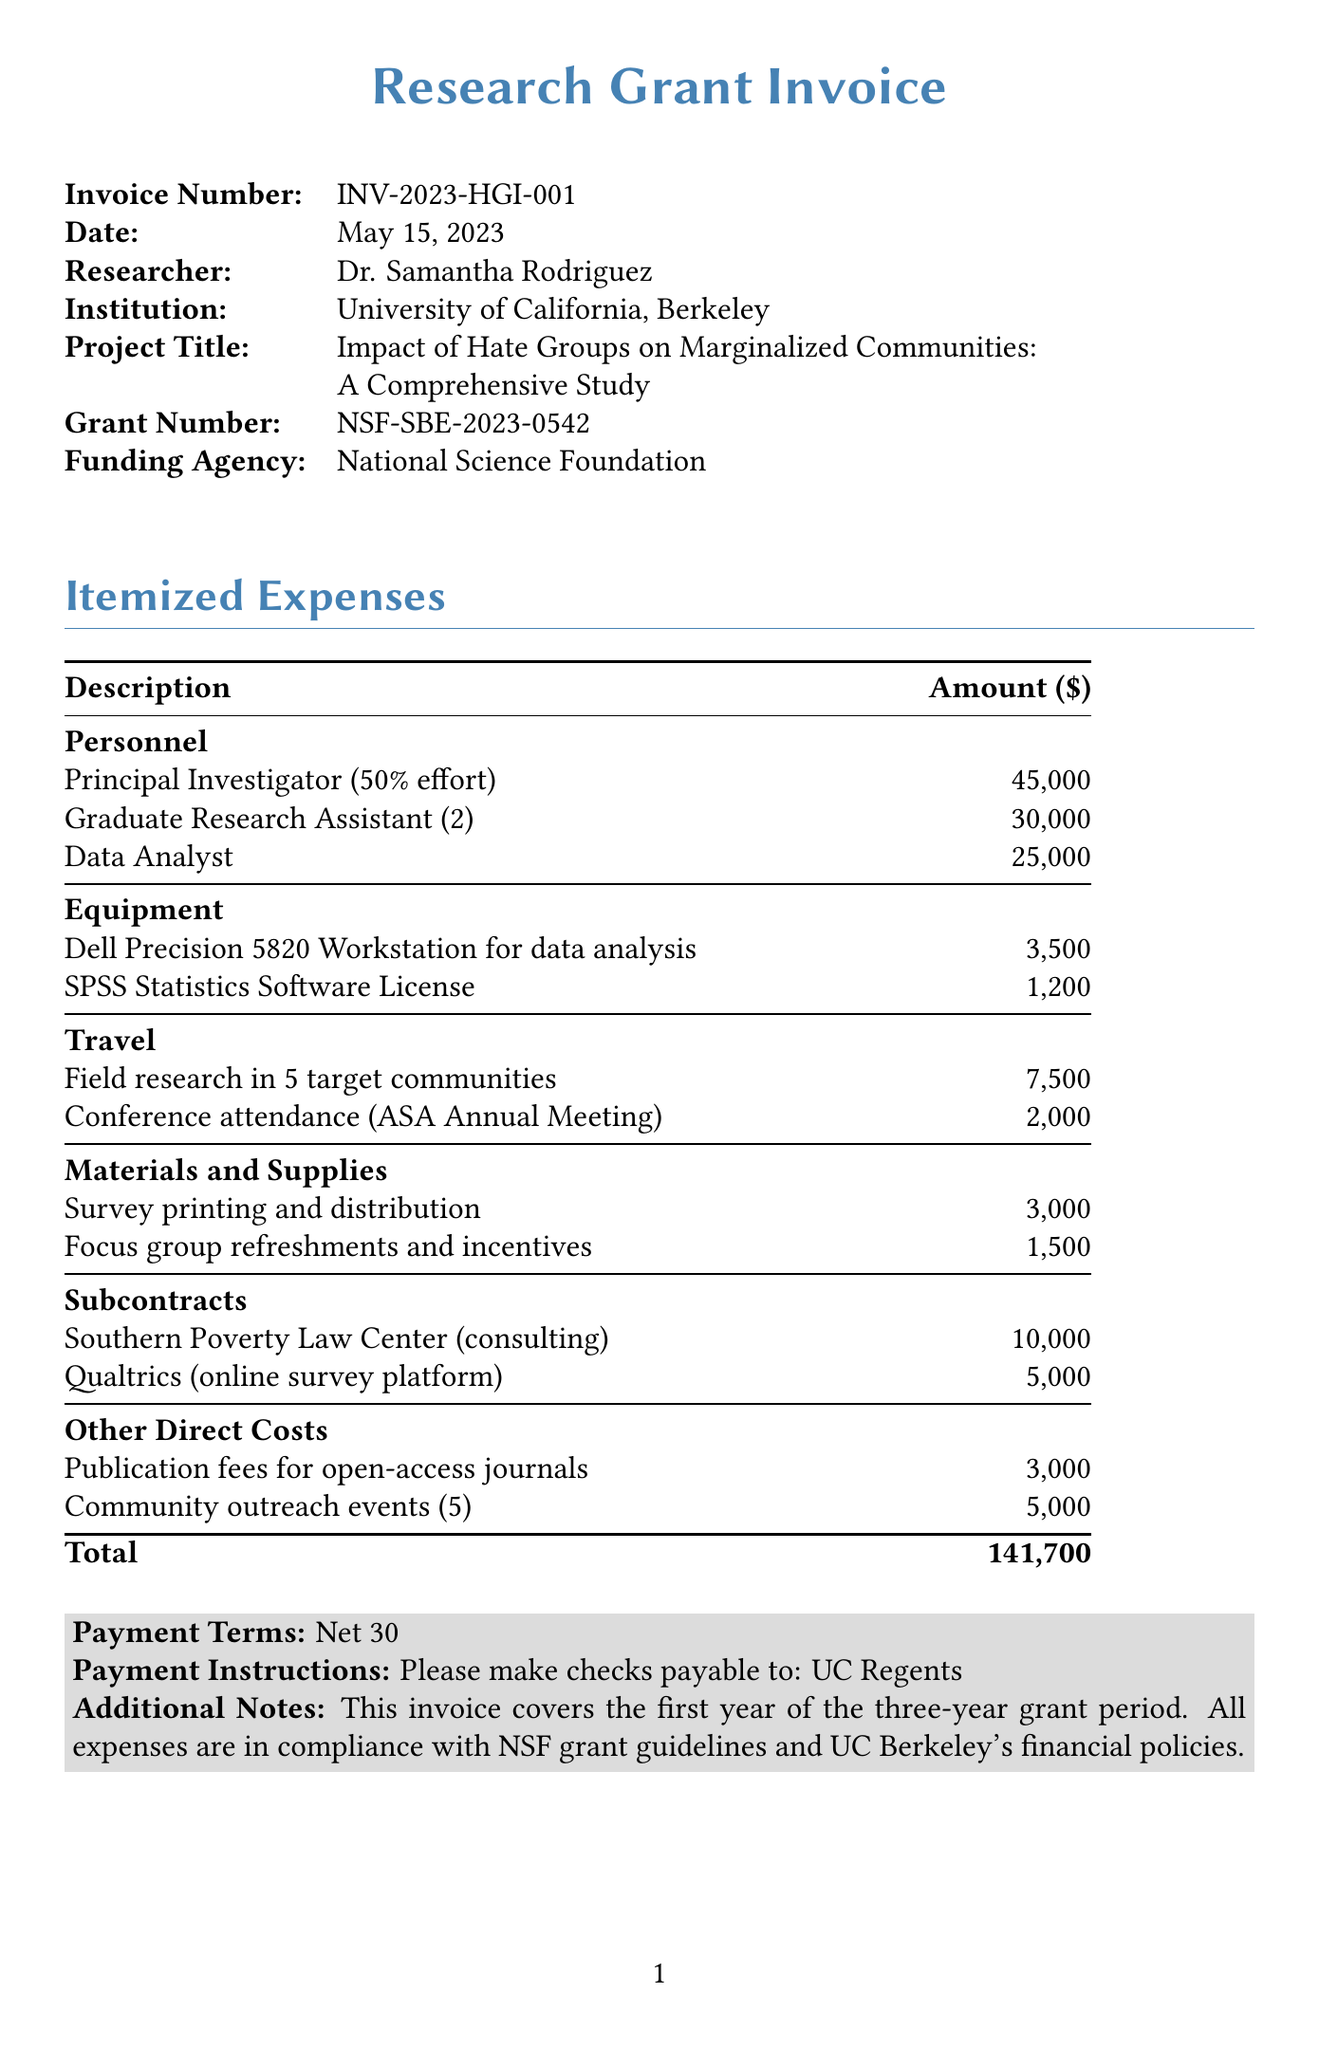What is the invoice number? The invoice number is listed at the top of the document, identifying this particular invoice.
Answer: INV-2023-HGI-001 Who is the principal investigator? The principal investigator is the leading researcher of the study, as mentioned in the personnel section.
Answer: Dr. Samantha Rodriguez What is the total amount of the invoice? The total amount is the sum of all the itemized expenses detailed in the invoice.
Answer: 141700 How many graduate research assistants are listed? The document specifies the number of graduate research assistants under the personnel section.
Answer: 2 What category does the survey printing and distribution expense fall under? The category for survey printing is shown in the itemized expenses section of the invoice.
Answer: Materials and Supplies How much is allocated for community outreach events? The amount for community outreach events is stated under the other direct costs section of the invoice.
Answer: 5000 What is the payment term specified in the document? The payment terms indicate the timeframe for payment as stated at the bottom of the invoice.
Answer: Net 30 What equipment is listed for data analysis? The document includes specific equipment needed for the research, particularly for data analysis.
Answer: Dell Precision 5820 Workstation for data analysis What agency is providing the funding for this research grant? The funding agency is identified at the beginning of the invoice.
Answer: National Science Foundation 